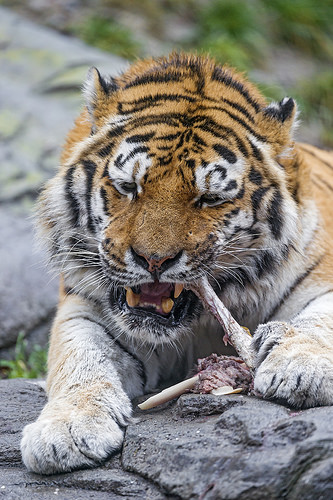<image>
Is the bone under the paw? Yes. The bone is positioned underneath the paw, with the paw above it in the vertical space. Is the bone in the tiger? Yes. The bone is contained within or inside the tiger, showing a containment relationship. 